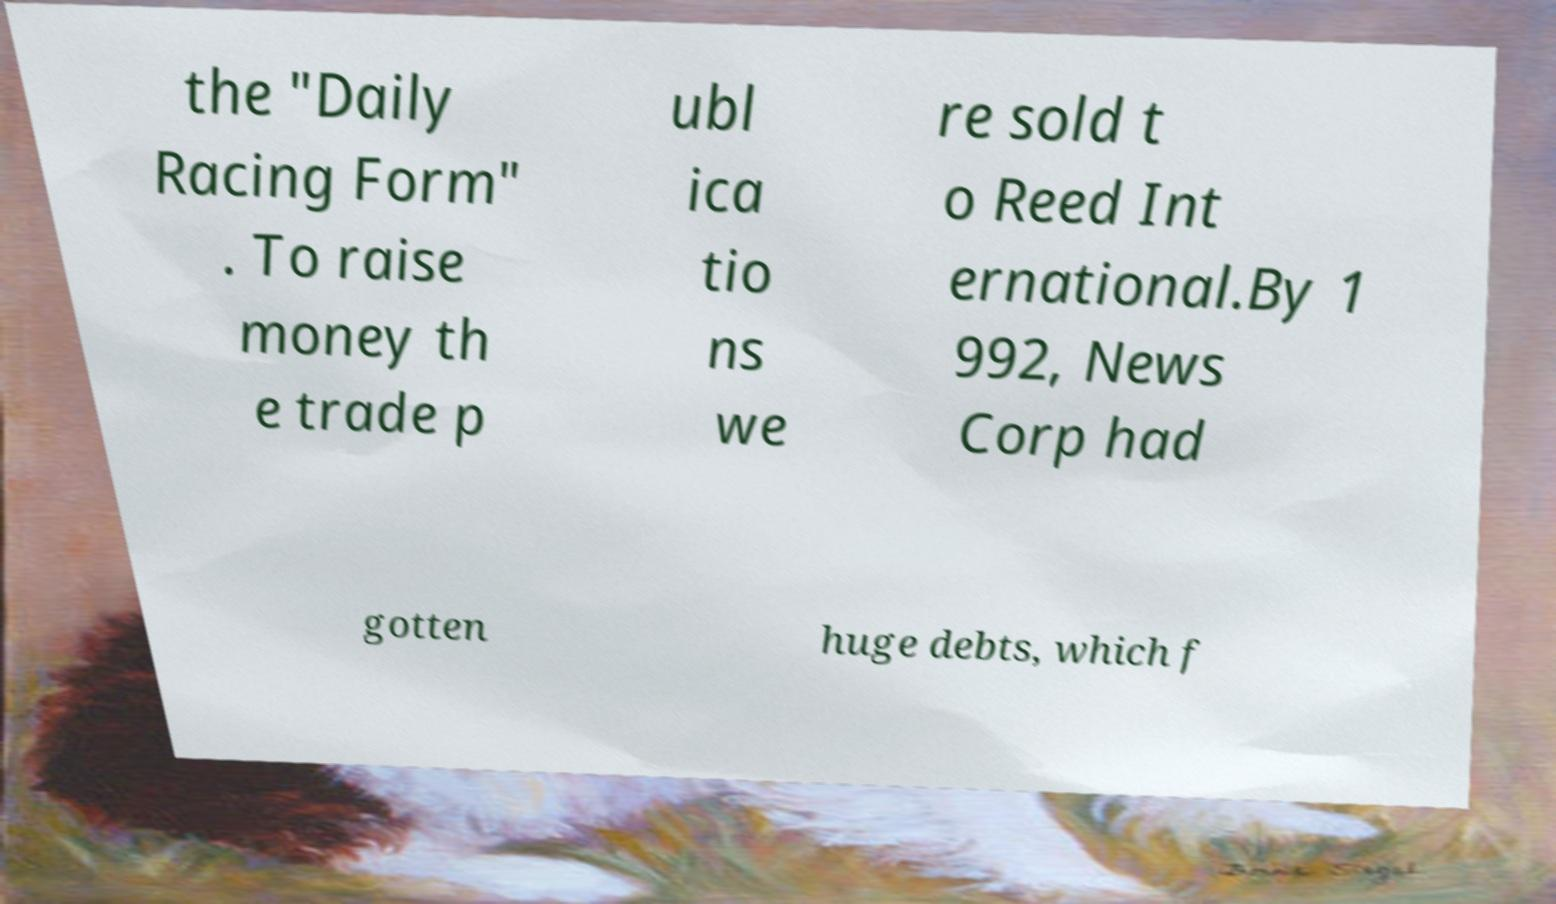I need the written content from this picture converted into text. Can you do that? the "Daily Racing Form" . To raise money th e trade p ubl ica tio ns we re sold t o Reed Int ernational.By 1 992, News Corp had gotten huge debts, which f 